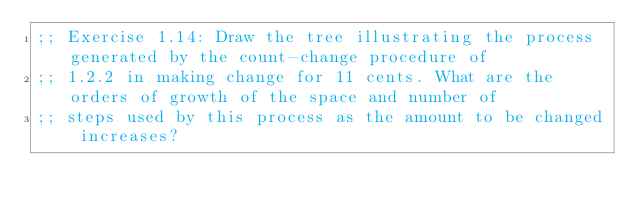<code> <loc_0><loc_0><loc_500><loc_500><_Lisp_>;; Exercise 1.14: Draw the tree illustrating the process generated by the count-change procedure of
;; 1.2.2 in making change for 11 cents. What are the orders of growth of the space and number of
;; steps used by this process as the amount to be changed increases?
</code> 